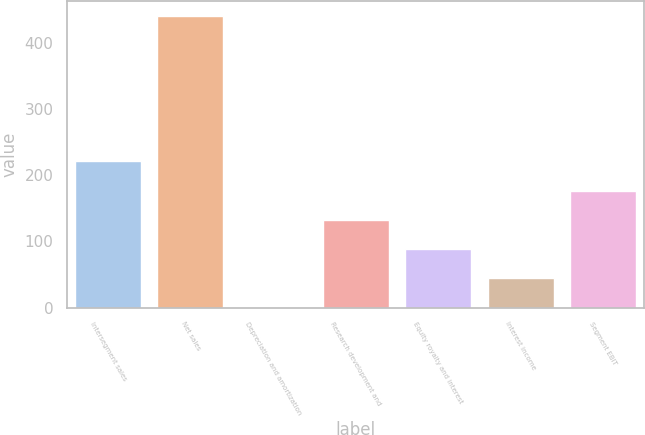Convert chart to OTSL. <chart><loc_0><loc_0><loc_500><loc_500><bar_chart><fcel>Intersegment sales<fcel>Net sales<fcel>Depreciation and amortization<fcel>Research development and<fcel>Equity royalty and interest<fcel>Interest income<fcel>Segment EBIT<nl><fcel>220.5<fcel>440<fcel>1<fcel>132.7<fcel>88.8<fcel>44.9<fcel>176.6<nl></chart> 